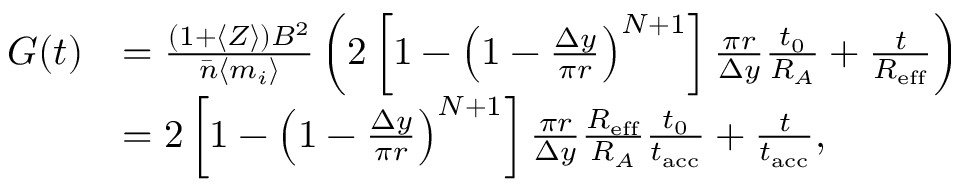Convert formula to latex. <formula><loc_0><loc_0><loc_500><loc_500>\begin{array} { r l } { G ( t ) } & { = \frac { ( 1 + \langle Z \rangle ) B ^ { 2 } } { \bar { n } \langle m _ { i } \rangle } \left ( 2 \left [ 1 - \left ( 1 - \frac { \Delta y } { \pi r } \right ) ^ { N + 1 } \right ] \frac { \pi r } { \Delta y } \frac { t _ { 0 } } { R _ { A } } + \frac { t } { R _ { e f f } } \right ) } \\ & { = 2 \left [ 1 - \left ( 1 - \frac { \Delta y } { \pi r } \right ) ^ { N + 1 } \right ] \frac { \pi r } { \Delta y } \frac { R _ { e f f } } { R _ { A } } \frac { t _ { 0 } } { t _ { a c c } } + \frac { t } { t _ { a c c } } , } \end{array}</formula> 